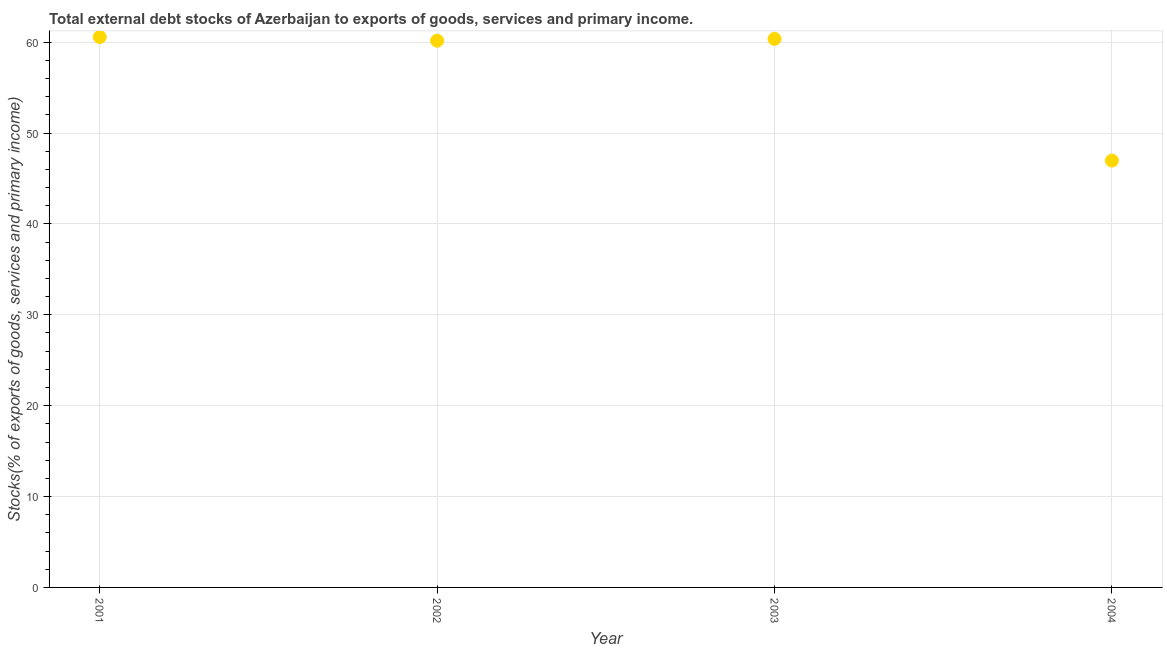What is the external debt stocks in 2004?
Give a very brief answer. 46.97. Across all years, what is the maximum external debt stocks?
Your response must be concise. 60.57. Across all years, what is the minimum external debt stocks?
Your response must be concise. 46.97. In which year was the external debt stocks minimum?
Ensure brevity in your answer.  2004. What is the sum of the external debt stocks?
Offer a very short reply. 228.06. What is the difference between the external debt stocks in 2001 and 2002?
Your answer should be compact. 0.4. What is the average external debt stocks per year?
Give a very brief answer. 57.02. What is the median external debt stocks?
Provide a succinct answer. 60.26. In how many years, is the external debt stocks greater than 22 %?
Provide a short and direct response. 4. Do a majority of the years between 2003 and 2004 (inclusive) have external debt stocks greater than 32 %?
Your answer should be compact. Yes. What is the ratio of the external debt stocks in 2001 to that in 2002?
Offer a terse response. 1.01. Is the difference between the external debt stocks in 2001 and 2004 greater than the difference between any two years?
Keep it short and to the point. Yes. What is the difference between the highest and the second highest external debt stocks?
Offer a terse response. 0.21. What is the difference between the highest and the lowest external debt stocks?
Your response must be concise. 13.6. In how many years, is the external debt stocks greater than the average external debt stocks taken over all years?
Your answer should be very brief. 3. Does the external debt stocks monotonically increase over the years?
Your answer should be compact. No. How many dotlines are there?
Offer a terse response. 1. Does the graph contain grids?
Ensure brevity in your answer.  Yes. What is the title of the graph?
Give a very brief answer. Total external debt stocks of Azerbaijan to exports of goods, services and primary income. What is the label or title of the X-axis?
Provide a succinct answer. Year. What is the label or title of the Y-axis?
Your answer should be compact. Stocks(% of exports of goods, services and primary income). What is the Stocks(% of exports of goods, services and primary income) in 2001?
Ensure brevity in your answer.  60.57. What is the Stocks(% of exports of goods, services and primary income) in 2002?
Your response must be concise. 60.16. What is the Stocks(% of exports of goods, services and primary income) in 2003?
Make the answer very short. 60.36. What is the Stocks(% of exports of goods, services and primary income) in 2004?
Keep it short and to the point. 46.97. What is the difference between the Stocks(% of exports of goods, services and primary income) in 2001 and 2002?
Your answer should be compact. 0.4. What is the difference between the Stocks(% of exports of goods, services and primary income) in 2001 and 2003?
Your response must be concise. 0.21. What is the difference between the Stocks(% of exports of goods, services and primary income) in 2001 and 2004?
Provide a short and direct response. 13.6. What is the difference between the Stocks(% of exports of goods, services and primary income) in 2002 and 2003?
Your answer should be very brief. -0.19. What is the difference between the Stocks(% of exports of goods, services and primary income) in 2002 and 2004?
Ensure brevity in your answer.  13.2. What is the difference between the Stocks(% of exports of goods, services and primary income) in 2003 and 2004?
Ensure brevity in your answer.  13.39. What is the ratio of the Stocks(% of exports of goods, services and primary income) in 2001 to that in 2002?
Give a very brief answer. 1.01. What is the ratio of the Stocks(% of exports of goods, services and primary income) in 2001 to that in 2004?
Provide a succinct answer. 1.29. What is the ratio of the Stocks(% of exports of goods, services and primary income) in 2002 to that in 2003?
Offer a very short reply. 1. What is the ratio of the Stocks(% of exports of goods, services and primary income) in 2002 to that in 2004?
Your response must be concise. 1.28. What is the ratio of the Stocks(% of exports of goods, services and primary income) in 2003 to that in 2004?
Offer a terse response. 1.28. 